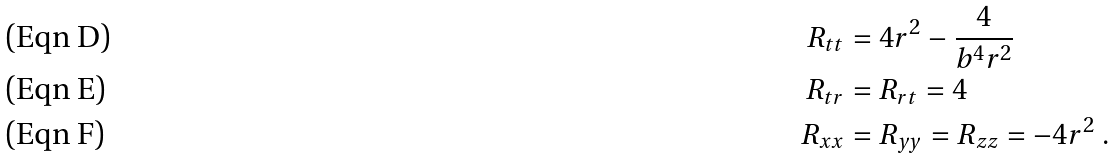Convert formula to latex. <formula><loc_0><loc_0><loc_500><loc_500>R _ { t t } & = 4 r ^ { 2 } - \frac { 4 } { b ^ { 4 } r ^ { 2 } } \\ R _ { t r } & = R _ { r t } = 4 \\ R _ { x x } & = R _ { y y } = R _ { z z } = - 4 r ^ { 2 } \ .</formula> 